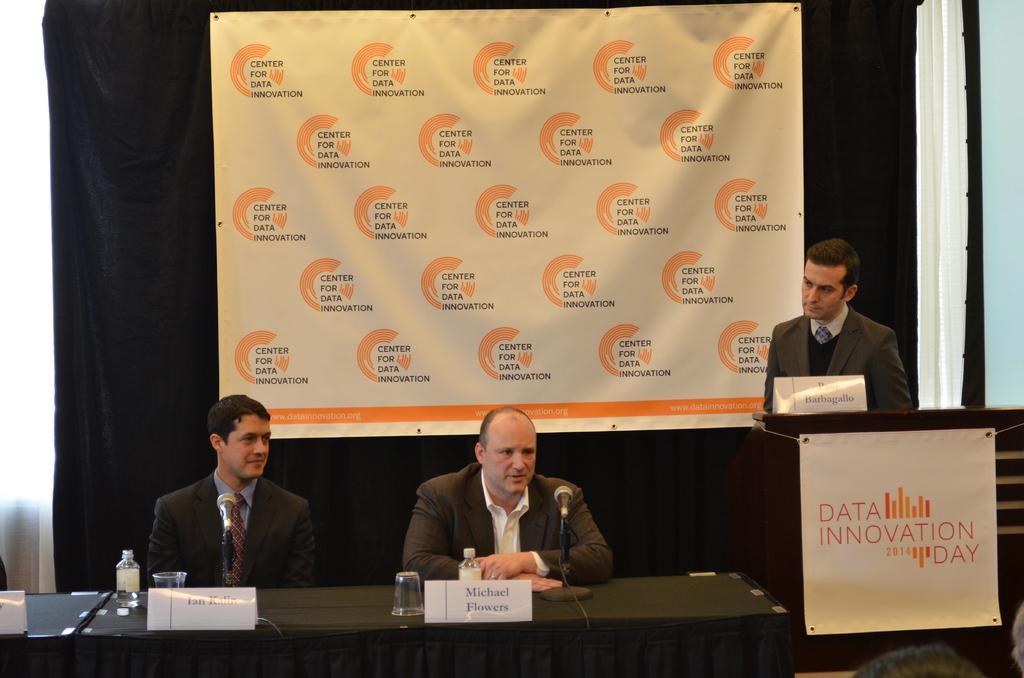In one or two sentences, can you explain what this image depicts? In this image we can see a man standing beside a speaker stand containing a name board and a banner with some text on it. We can also see some people sitting on the chairs beside a table containing some glasses, name boards, bottles and the mics with stands which are placed on it. On the backside we can see a banner with some text, a curtain and a wall. At the bottom right we can see some people. 